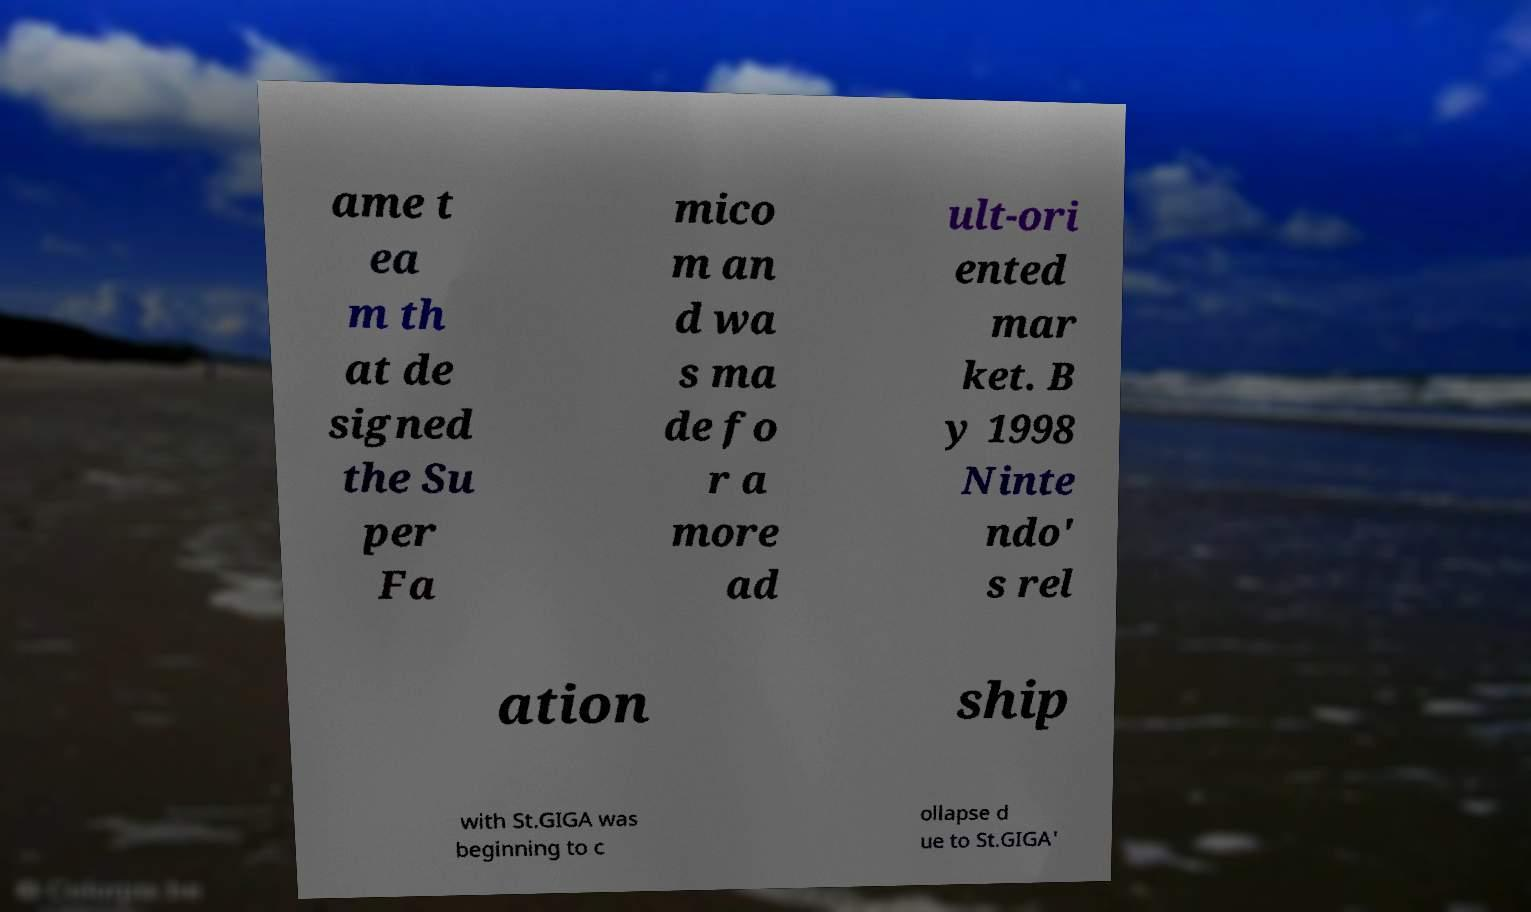Could you assist in decoding the text presented in this image and type it out clearly? ame t ea m th at de signed the Su per Fa mico m an d wa s ma de fo r a more ad ult-ori ented mar ket. B y 1998 Ninte ndo' s rel ation ship with St.GIGA was beginning to c ollapse d ue to St.GIGA' 